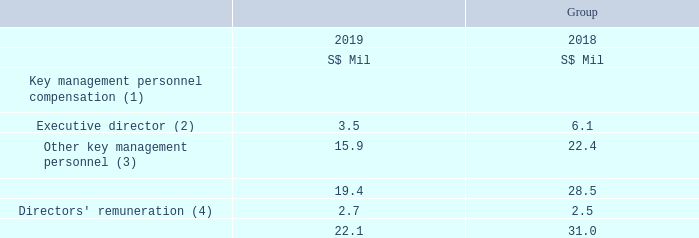5.2 Key Management Personnel Compensation
Notes: (1) Comprise base salary, bonus, contributions to defined contribution plans and other benefits, but exclude performance share and share option expenses disclosed below.
(2) The Group Chief Executive Officer, an executive director of Singtel, was awarded up to 1,030,168 (2018: 1,712,538) ordinary shares of Singtel pursuant to Singtel performance share plans, subject to certain performance criteria including other terms and conditions being met. The performance share award in the previous financial year included a one-off Special Share Award (“SSA”). The performance share expense computed in accordance with SFRS(I) 2, Share-based Payment, was S$1.5 million (2018: S$3.3 million).
(3) The other key management personnel of the Group comprise the Chief Executive Officers of Consumer Singapore, Consumer Australia, Group Enterprise, Group Digital Life and International Group, as well as the Group Chief Corporate Officer, Group Chief Financial Officer, Group Chief Human Resources Officer, Group Chief Information Officer and Group Chief Technology Officer. The other key management personnel were awarded up to 3,537,119 (2018: 4,391,498) ordinary shares of Singtel pursuant to Singtel performance share plans, subject to certain performance criteria including other terms and conditions being met. The performance share award in the previous financial year included a one-off SSA. The performance share expense computed in accordance with SFRS(I) 2 was S$6.1 million (2018: S$8.5 million).
(4) Directors’ remuneration comprises the following: (i) Directors’ fees of S$2.7 million (2018: S$2.5 million), including fees paid to certain directors in their capacities as members of the Optus Advisory Committee and the Technology Advisory Panel, and as director of Singtel Innov8 Pte. Ltd. (ii) Car-related benefits of the Chairman of S$24,557 (2018: S$20,446). In addition to the Directors’ remuneration, Venkataraman Vishnampet Ganesan, a non-executive director of Singtel, was awarded 831,087 (2018: Nil) of share options pursuant to the Amobee Long-Term Incentive Plan during the financial year, subject to certain terms and conditions being met. The share option expense computed in accordance with SFRS(I) 2 was S$104,278 (2018: S$21,607).
What does key management personnel compensation comprise? Comprise base salary, bonus, contributions to defined contribution plans and other benefits, but exclude performance share and share option expenses disclosed below. What does directors' remuneration comprise of? Directors’ fees, car-related benefits of the chairman. How many ordinary shares of Singtel was the Group Chief Executive Officer awarded in 2019? Up to 1,030,168. What is the % change in key management personnel compensation from 2018 to 2019, excluding directors' remuneration?
Answer scale should be: percent. (19.4 - 28.5) / 28.5
Answer: -31.93. How many subcategories are there that make up key management personnel compensation? Executive director##Other key management personnel##Directors' remuneration
Answer: 3. Under other key management personnel of the group, how many executive directors are included? Chief Executive Officers of Consumer Singapore##Consumer Australia##Group Enterprise##Group Digital Life##International Group##Group Chief Corporate Officer##Group Chief Financial Officer##Group Chief Human Resources Officer##Group Chief Information Officer##Group Chief Technology Officer
Answer: 10. 